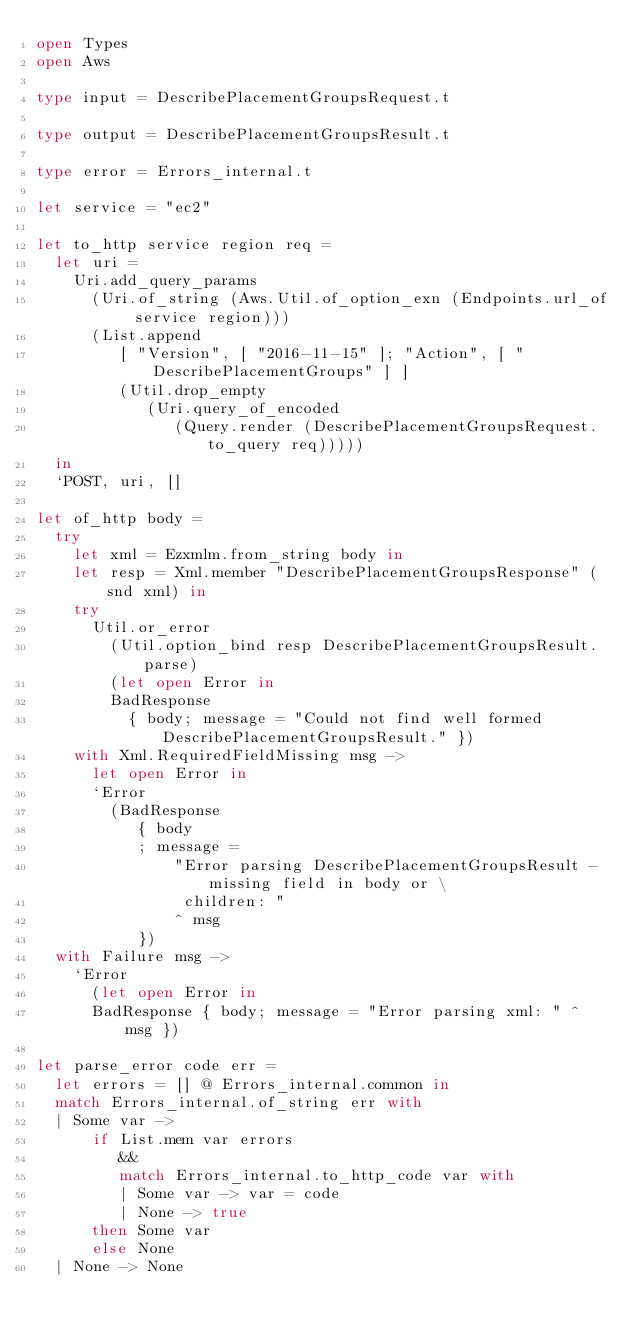<code> <loc_0><loc_0><loc_500><loc_500><_OCaml_>open Types
open Aws

type input = DescribePlacementGroupsRequest.t

type output = DescribePlacementGroupsResult.t

type error = Errors_internal.t

let service = "ec2"

let to_http service region req =
  let uri =
    Uri.add_query_params
      (Uri.of_string (Aws.Util.of_option_exn (Endpoints.url_of service region)))
      (List.append
         [ "Version", [ "2016-11-15" ]; "Action", [ "DescribePlacementGroups" ] ]
         (Util.drop_empty
            (Uri.query_of_encoded
               (Query.render (DescribePlacementGroupsRequest.to_query req)))))
  in
  `POST, uri, []

let of_http body =
  try
    let xml = Ezxmlm.from_string body in
    let resp = Xml.member "DescribePlacementGroupsResponse" (snd xml) in
    try
      Util.or_error
        (Util.option_bind resp DescribePlacementGroupsResult.parse)
        (let open Error in
        BadResponse
          { body; message = "Could not find well formed DescribePlacementGroupsResult." })
    with Xml.RequiredFieldMissing msg ->
      let open Error in
      `Error
        (BadResponse
           { body
           ; message =
               "Error parsing DescribePlacementGroupsResult - missing field in body or \
                children: "
               ^ msg
           })
  with Failure msg ->
    `Error
      (let open Error in
      BadResponse { body; message = "Error parsing xml: " ^ msg })

let parse_error code err =
  let errors = [] @ Errors_internal.common in
  match Errors_internal.of_string err with
  | Some var ->
      if List.mem var errors
         &&
         match Errors_internal.to_http_code var with
         | Some var -> var = code
         | None -> true
      then Some var
      else None
  | None -> None
</code> 